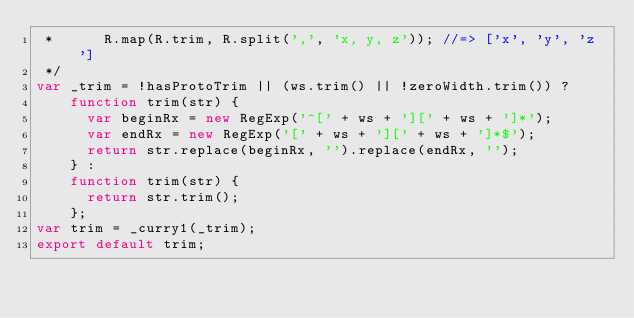Convert code to text. <code><loc_0><loc_0><loc_500><loc_500><_JavaScript_> *      R.map(R.trim, R.split(',', 'x, y, z')); //=> ['x', 'y', 'z']
 */
var _trim = !hasProtoTrim || (ws.trim() || !zeroWidth.trim()) ?
    function trim(str) {
      var beginRx = new RegExp('^[' + ws + '][' + ws + ']*');
      var endRx = new RegExp('[' + ws + '][' + ws + ']*$');
      return str.replace(beginRx, '').replace(endRx, '');
    } :
    function trim(str) {
      return str.trim();
    };
var trim = _curry1(_trim);
export default trim;
</code> 